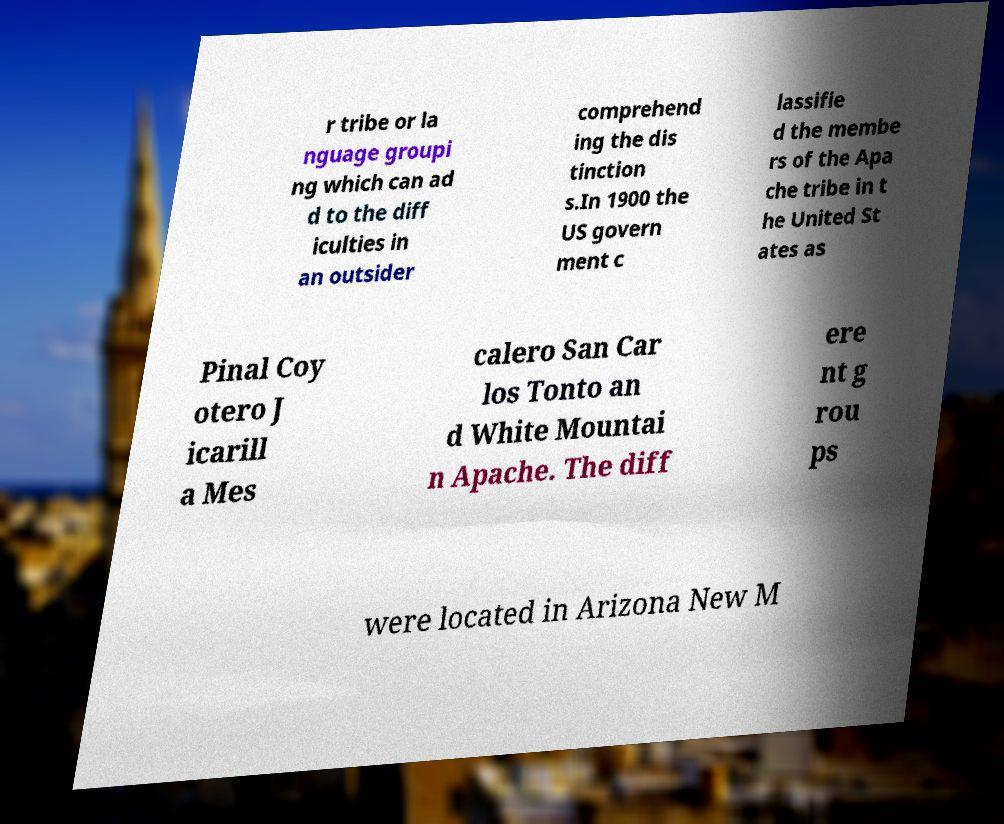Could you assist in decoding the text presented in this image and type it out clearly? r tribe or la nguage groupi ng which can ad d to the diff iculties in an outsider comprehend ing the dis tinction s.In 1900 the US govern ment c lassifie d the membe rs of the Apa che tribe in t he United St ates as Pinal Coy otero J icarill a Mes calero San Car los Tonto an d White Mountai n Apache. The diff ere nt g rou ps were located in Arizona New M 